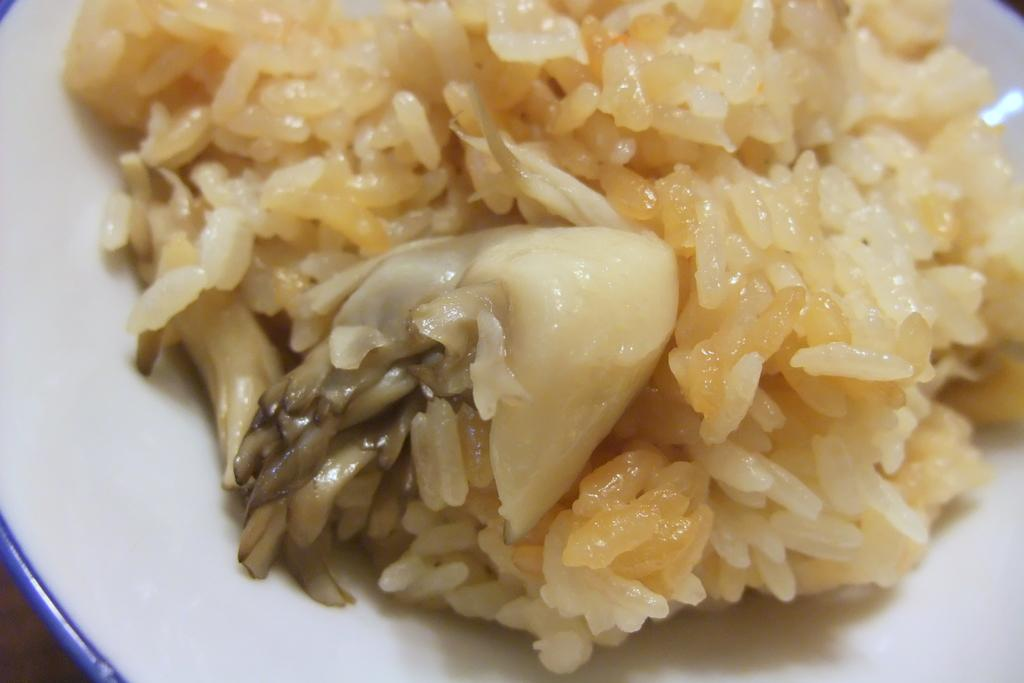What is the color of the plate in the image? The plate in the image is white. What type of food is on the plate? The plate contains yellow-colored food. What type of hose is connected to the plate in the image? There is no hose connected to the plate in the image. Who is the partner of the person eating the food on the plate? The image does not show any people, so it is impossible to determine who the partner of the person eating the food might be. 